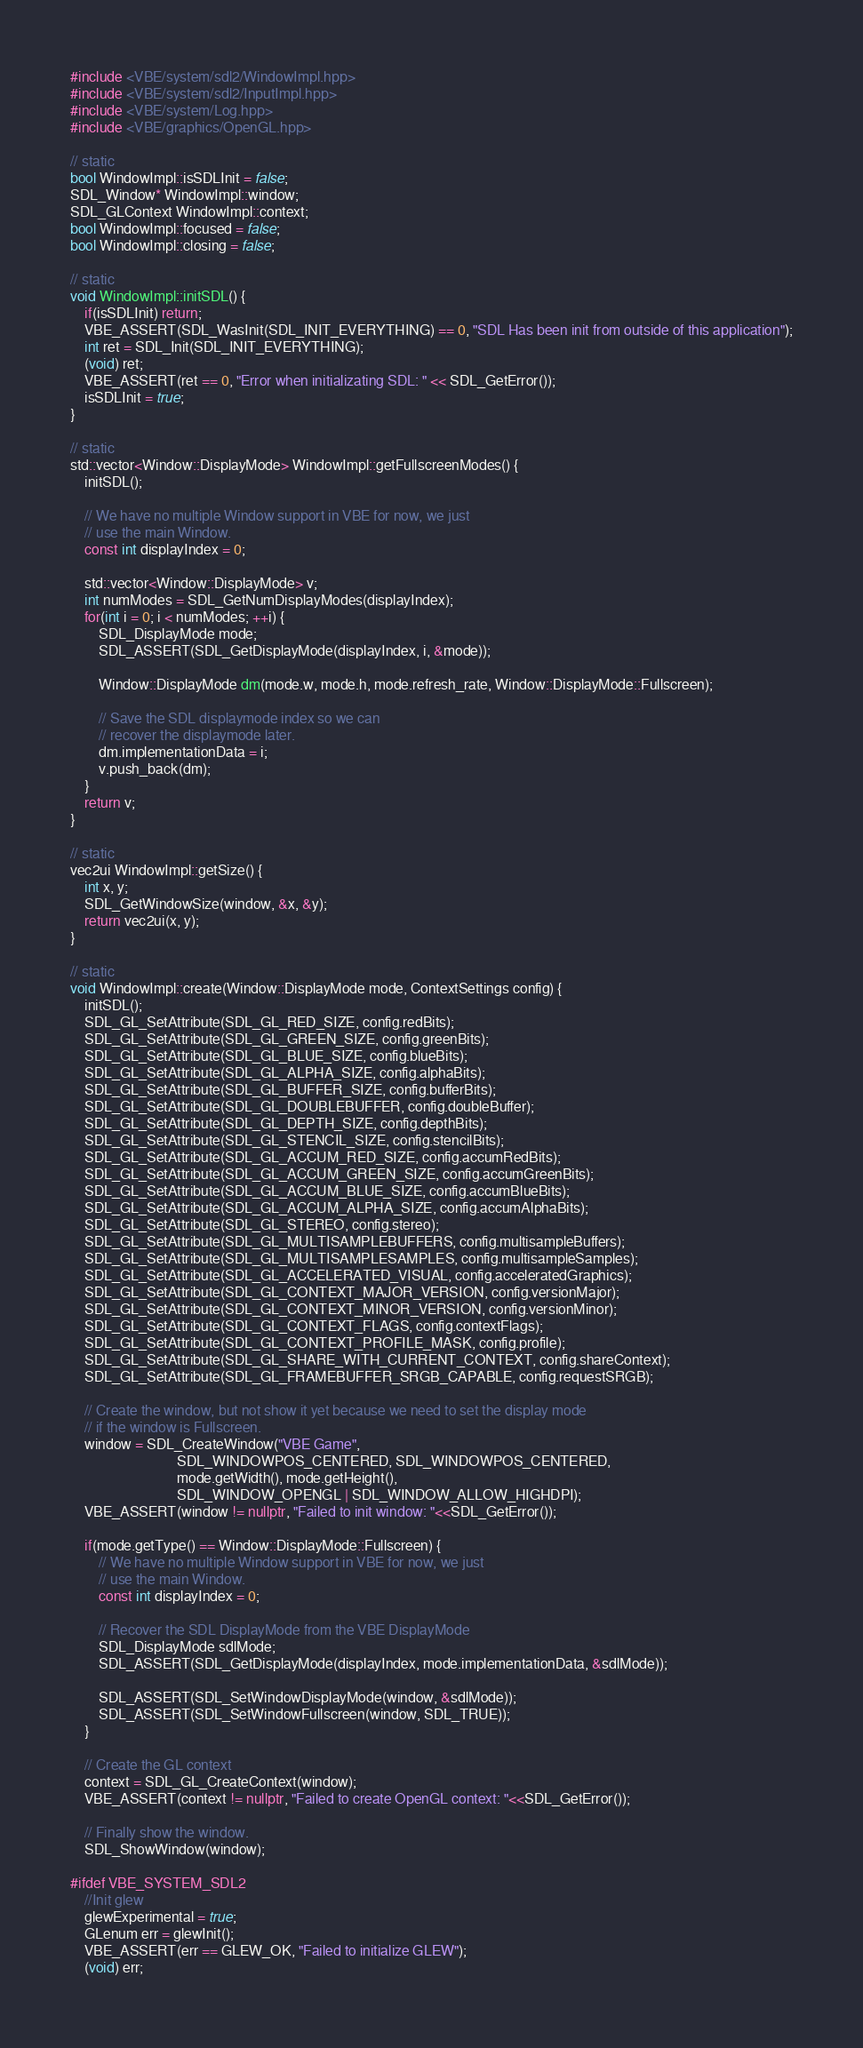Convert code to text. <code><loc_0><loc_0><loc_500><loc_500><_C++_>#include <VBE/system/sdl2/WindowImpl.hpp>
#include <VBE/system/sdl2/InputImpl.hpp>
#include <VBE/system/Log.hpp>
#include <VBE/graphics/OpenGL.hpp>

// static
bool WindowImpl::isSDLInit = false;
SDL_Window* WindowImpl::window;
SDL_GLContext WindowImpl::context;
bool WindowImpl::focused = false;
bool WindowImpl::closing = false;

// static
void WindowImpl::initSDL() {
    if(isSDLInit) return;
    VBE_ASSERT(SDL_WasInit(SDL_INIT_EVERYTHING) == 0, "SDL Has been init from outside of this application");
    int ret = SDL_Init(SDL_INIT_EVERYTHING);
    (void) ret;
    VBE_ASSERT(ret == 0, "Error when initializating SDL: " << SDL_GetError());
    isSDLInit = true;
}

// static
std::vector<Window::DisplayMode> WindowImpl::getFullscreenModes() {
    initSDL();

    // We have no multiple Window support in VBE for now, we just
    // use the main Window.
    const int displayIndex = 0;

    std::vector<Window::DisplayMode> v;
    int numModes = SDL_GetNumDisplayModes(displayIndex);
    for(int i = 0; i < numModes; ++i) {
        SDL_DisplayMode mode;
        SDL_ASSERT(SDL_GetDisplayMode(displayIndex, i, &mode));

        Window::DisplayMode dm(mode.w, mode.h, mode.refresh_rate, Window::DisplayMode::Fullscreen);

        // Save the SDL displaymode index so we can
        // recover the displaymode later.
        dm.implementationData = i;
        v.push_back(dm);
    }
    return v;
}

// static
vec2ui WindowImpl::getSize() {
    int x, y;
    SDL_GetWindowSize(window, &x, &y);
    return vec2ui(x, y);
}

// static
void WindowImpl::create(Window::DisplayMode mode, ContextSettings config) {
    initSDL();
    SDL_GL_SetAttribute(SDL_GL_RED_SIZE, config.redBits);
    SDL_GL_SetAttribute(SDL_GL_GREEN_SIZE, config.greenBits);
    SDL_GL_SetAttribute(SDL_GL_BLUE_SIZE, config.blueBits);
    SDL_GL_SetAttribute(SDL_GL_ALPHA_SIZE, config.alphaBits);
    SDL_GL_SetAttribute(SDL_GL_BUFFER_SIZE, config.bufferBits);
    SDL_GL_SetAttribute(SDL_GL_DOUBLEBUFFER, config.doubleBuffer);
    SDL_GL_SetAttribute(SDL_GL_DEPTH_SIZE, config.depthBits);
    SDL_GL_SetAttribute(SDL_GL_STENCIL_SIZE, config.stencilBits);
    SDL_GL_SetAttribute(SDL_GL_ACCUM_RED_SIZE, config.accumRedBits);
    SDL_GL_SetAttribute(SDL_GL_ACCUM_GREEN_SIZE, config.accumGreenBits);
    SDL_GL_SetAttribute(SDL_GL_ACCUM_BLUE_SIZE, config.accumBlueBits);
    SDL_GL_SetAttribute(SDL_GL_ACCUM_ALPHA_SIZE, config.accumAlphaBits);
    SDL_GL_SetAttribute(SDL_GL_STEREO, config.stereo);
    SDL_GL_SetAttribute(SDL_GL_MULTISAMPLEBUFFERS, config.multisampleBuffers);
    SDL_GL_SetAttribute(SDL_GL_MULTISAMPLESAMPLES, config.multisampleSamples);
    SDL_GL_SetAttribute(SDL_GL_ACCELERATED_VISUAL, config.acceleratedGraphics);
    SDL_GL_SetAttribute(SDL_GL_CONTEXT_MAJOR_VERSION, config.versionMajor);
    SDL_GL_SetAttribute(SDL_GL_CONTEXT_MINOR_VERSION, config.versionMinor);
    SDL_GL_SetAttribute(SDL_GL_CONTEXT_FLAGS, config.contextFlags);
    SDL_GL_SetAttribute(SDL_GL_CONTEXT_PROFILE_MASK, config.profile);
    SDL_GL_SetAttribute(SDL_GL_SHARE_WITH_CURRENT_CONTEXT, config.shareContext);
    SDL_GL_SetAttribute(SDL_GL_FRAMEBUFFER_SRGB_CAPABLE, config.requestSRGB);

    // Create the window, but not show it yet because we need to set the display mode
    // if the window is Fullscreen.
    window = SDL_CreateWindow("VBE Game",
                              SDL_WINDOWPOS_CENTERED, SDL_WINDOWPOS_CENTERED,
                              mode.getWidth(), mode.getHeight(),
                              SDL_WINDOW_OPENGL | SDL_WINDOW_ALLOW_HIGHDPI);
    VBE_ASSERT(window != nullptr, "Failed to init window: "<<SDL_GetError());

    if(mode.getType() == Window::DisplayMode::Fullscreen) {
        // We have no multiple Window support in VBE for now, we just
        // use the main Window.
        const int displayIndex = 0;

        // Recover the SDL DisplayMode from the VBE DisplayMode
        SDL_DisplayMode sdlMode;
        SDL_ASSERT(SDL_GetDisplayMode(displayIndex, mode.implementationData, &sdlMode));

        SDL_ASSERT(SDL_SetWindowDisplayMode(window, &sdlMode));
        SDL_ASSERT(SDL_SetWindowFullscreen(window, SDL_TRUE));
    }

    // Create the GL context
    context = SDL_GL_CreateContext(window);
    VBE_ASSERT(context != nullptr, "Failed to create OpenGL context: "<<SDL_GetError());

    // Finally show the window.
    SDL_ShowWindow(window);

#ifdef VBE_SYSTEM_SDL2
    //Init glew
    glewExperimental = true;
    GLenum err = glewInit();
    VBE_ASSERT(err == GLEW_OK, "Failed to initialize GLEW");
    (void) err;</code> 